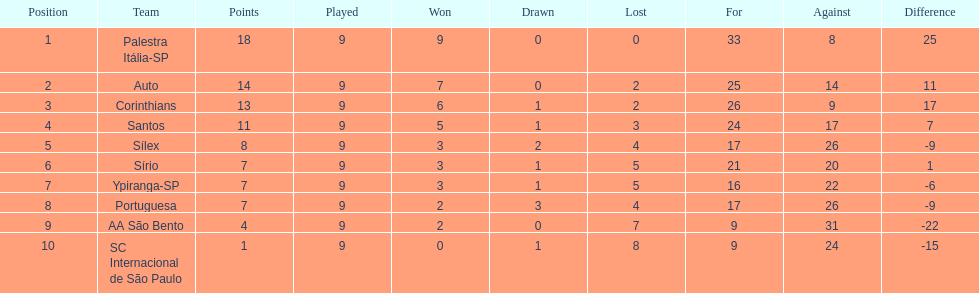During the 1926 brazilian football year, how many teams amassed upwards of 10 points? 4. 